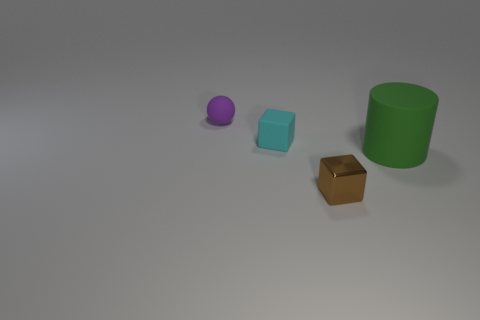Are there any other things that are the same size as the green rubber cylinder?
Your answer should be very brief. No. Are there any other things that are the same material as the brown object?
Your response must be concise. No. Does the big matte thing have the same shape as the object in front of the big rubber thing?
Your answer should be very brief. No. There is a object right of the tiny object that is to the right of the small rubber object in front of the ball; what is its material?
Offer a terse response. Rubber. What number of other objects are there of the same size as the green thing?
Provide a short and direct response. 0. There is a small rubber object that is on the left side of the small rubber thing in front of the purple object; what number of small brown objects are in front of it?
Your response must be concise. 1. There is a small object in front of the small block that is behind the large green matte object; what is its material?
Keep it short and to the point. Metal. Are there any matte things that have the same shape as the tiny metallic thing?
Give a very brief answer. Yes. There is a ball that is the same size as the rubber cube; what color is it?
Your answer should be compact. Purple. How many things are small things that are behind the metallic object or small cubes that are right of the tiny cyan rubber cube?
Provide a succinct answer. 3. 